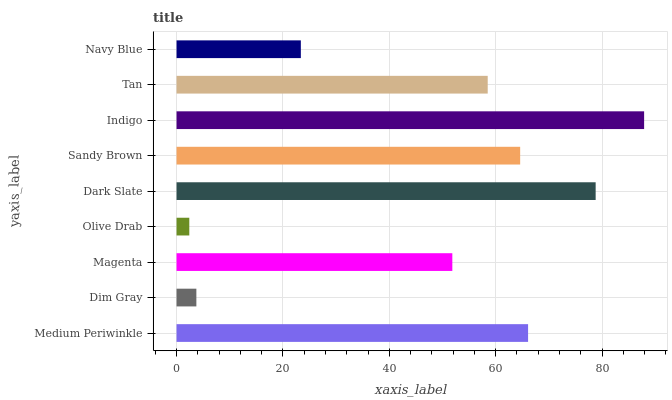Is Olive Drab the minimum?
Answer yes or no. Yes. Is Indigo the maximum?
Answer yes or no. Yes. Is Dim Gray the minimum?
Answer yes or no. No. Is Dim Gray the maximum?
Answer yes or no. No. Is Medium Periwinkle greater than Dim Gray?
Answer yes or no. Yes. Is Dim Gray less than Medium Periwinkle?
Answer yes or no. Yes. Is Dim Gray greater than Medium Periwinkle?
Answer yes or no. No. Is Medium Periwinkle less than Dim Gray?
Answer yes or no. No. Is Tan the high median?
Answer yes or no. Yes. Is Tan the low median?
Answer yes or no. Yes. Is Indigo the high median?
Answer yes or no. No. Is Medium Periwinkle the low median?
Answer yes or no. No. 